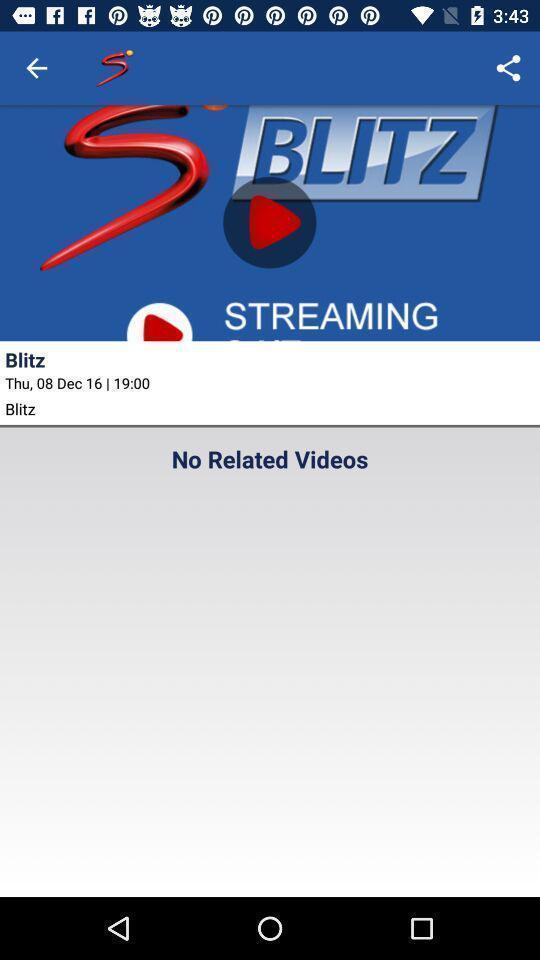Tell me what you see in this picture. Page displays a video in app. 